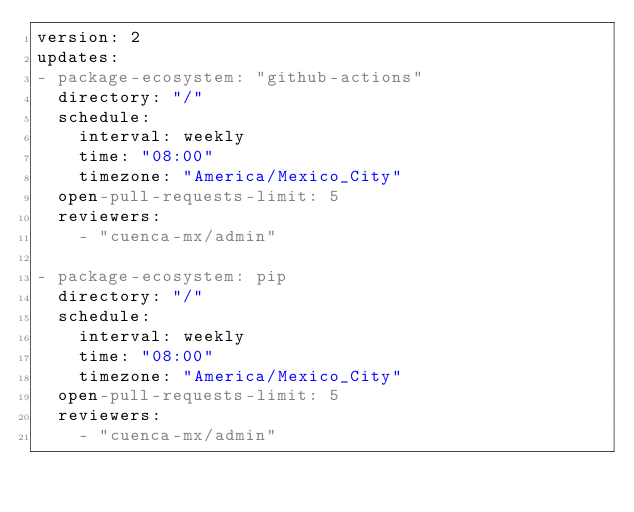Convert code to text. <code><loc_0><loc_0><loc_500><loc_500><_YAML_>version: 2
updates:
- package-ecosystem: "github-actions"
  directory: "/"
  schedule:
    interval: weekly
    time: "08:00"
    timezone: "America/Mexico_City"
  open-pull-requests-limit: 5
  reviewers:
    - "cuenca-mx/admin"

- package-ecosystem: pip
  directory: "/"
  schedule:
    interval: weekly
    time: "08:00"
    timezone: "America/Mexico_City"
  open-pull-requests-limit: 5
  reviewers:
    - "cuenca-mx/admin"
</code> 